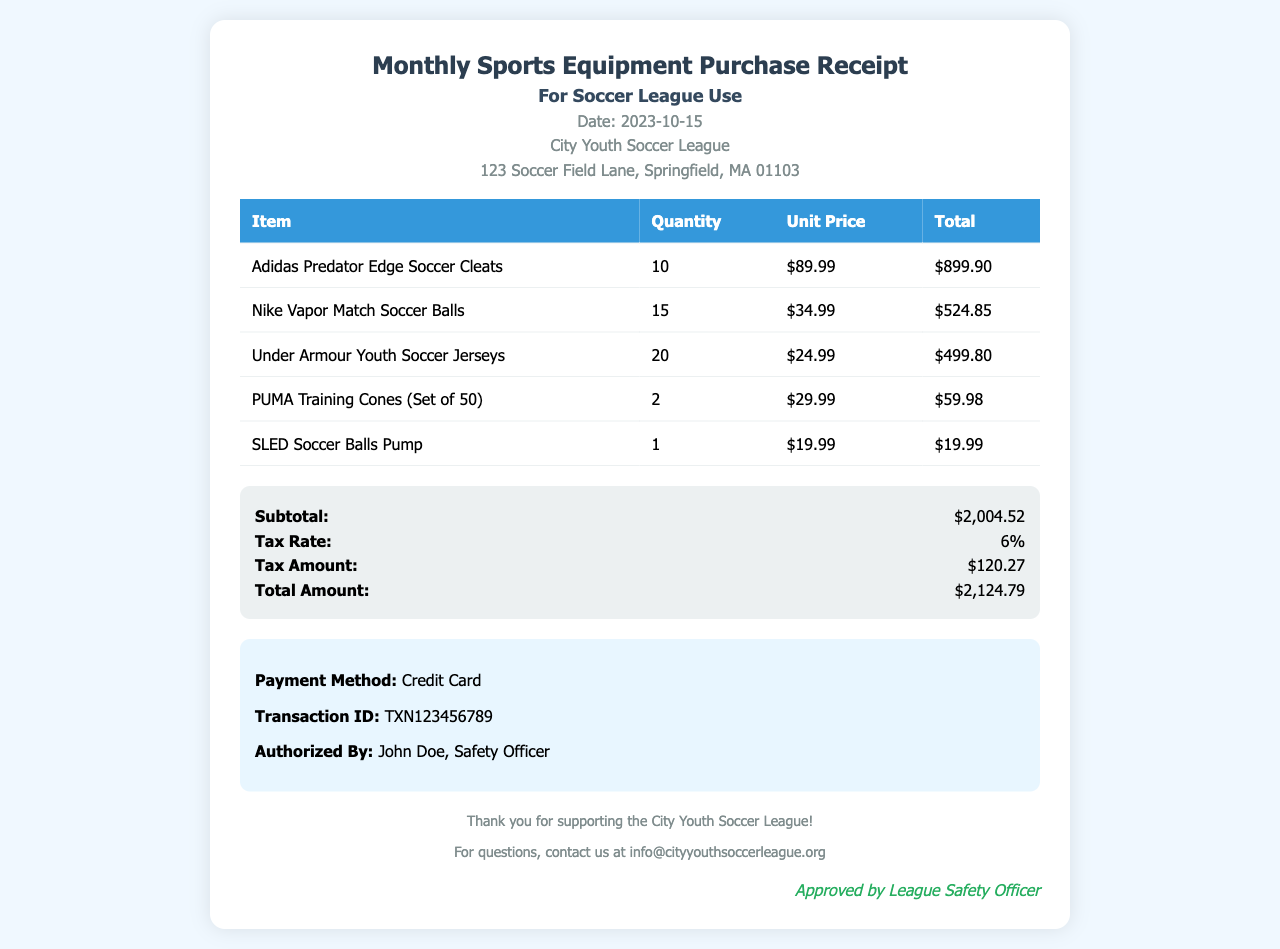What is the date of the receipt? The receipt date is explicitly mentioned in the document header as 2023-10-15.
Answer: 2023-10-15 What is the total amount of the purchase? The total amount is stated in the summary section of the document as $2,124.79.
Answer: $2,124.79 How many pairs of Adidas Predator Edge Soccer Cleats were purchased? The quantity of cleats purchased is specified as 10 in the table of items.
Answer: 10 Who authorized the payment? The authorized person's name is provided in the payment information section as John Doe.
Answer: John Doe What is the tax amount calculated on the purchase? The tax amount is detailed in the summary section as $120.27.
Answer: $120.27 Which item has the highest unit price? By inspecting the unit prices of items listed, Adidas Predator Edge Soccer Cleats have the highest price at $89.99 each.
Answer: Adidas Predator Edge Soccer Cleats How many Nike Vapor Match Soccer Balls were bought? The quantity of soccer balls purchased is indicated as 15 in the items table.
Answer: 15 What is the payment method used for this transaction? The payment method is explicitly described in the payment information section as Credit Card.
Answer: Credit Card What is the subtotal before tax is applied? The subtotal amount is listed in the summary section as $2,004.52.
Answer: $2,004.52 